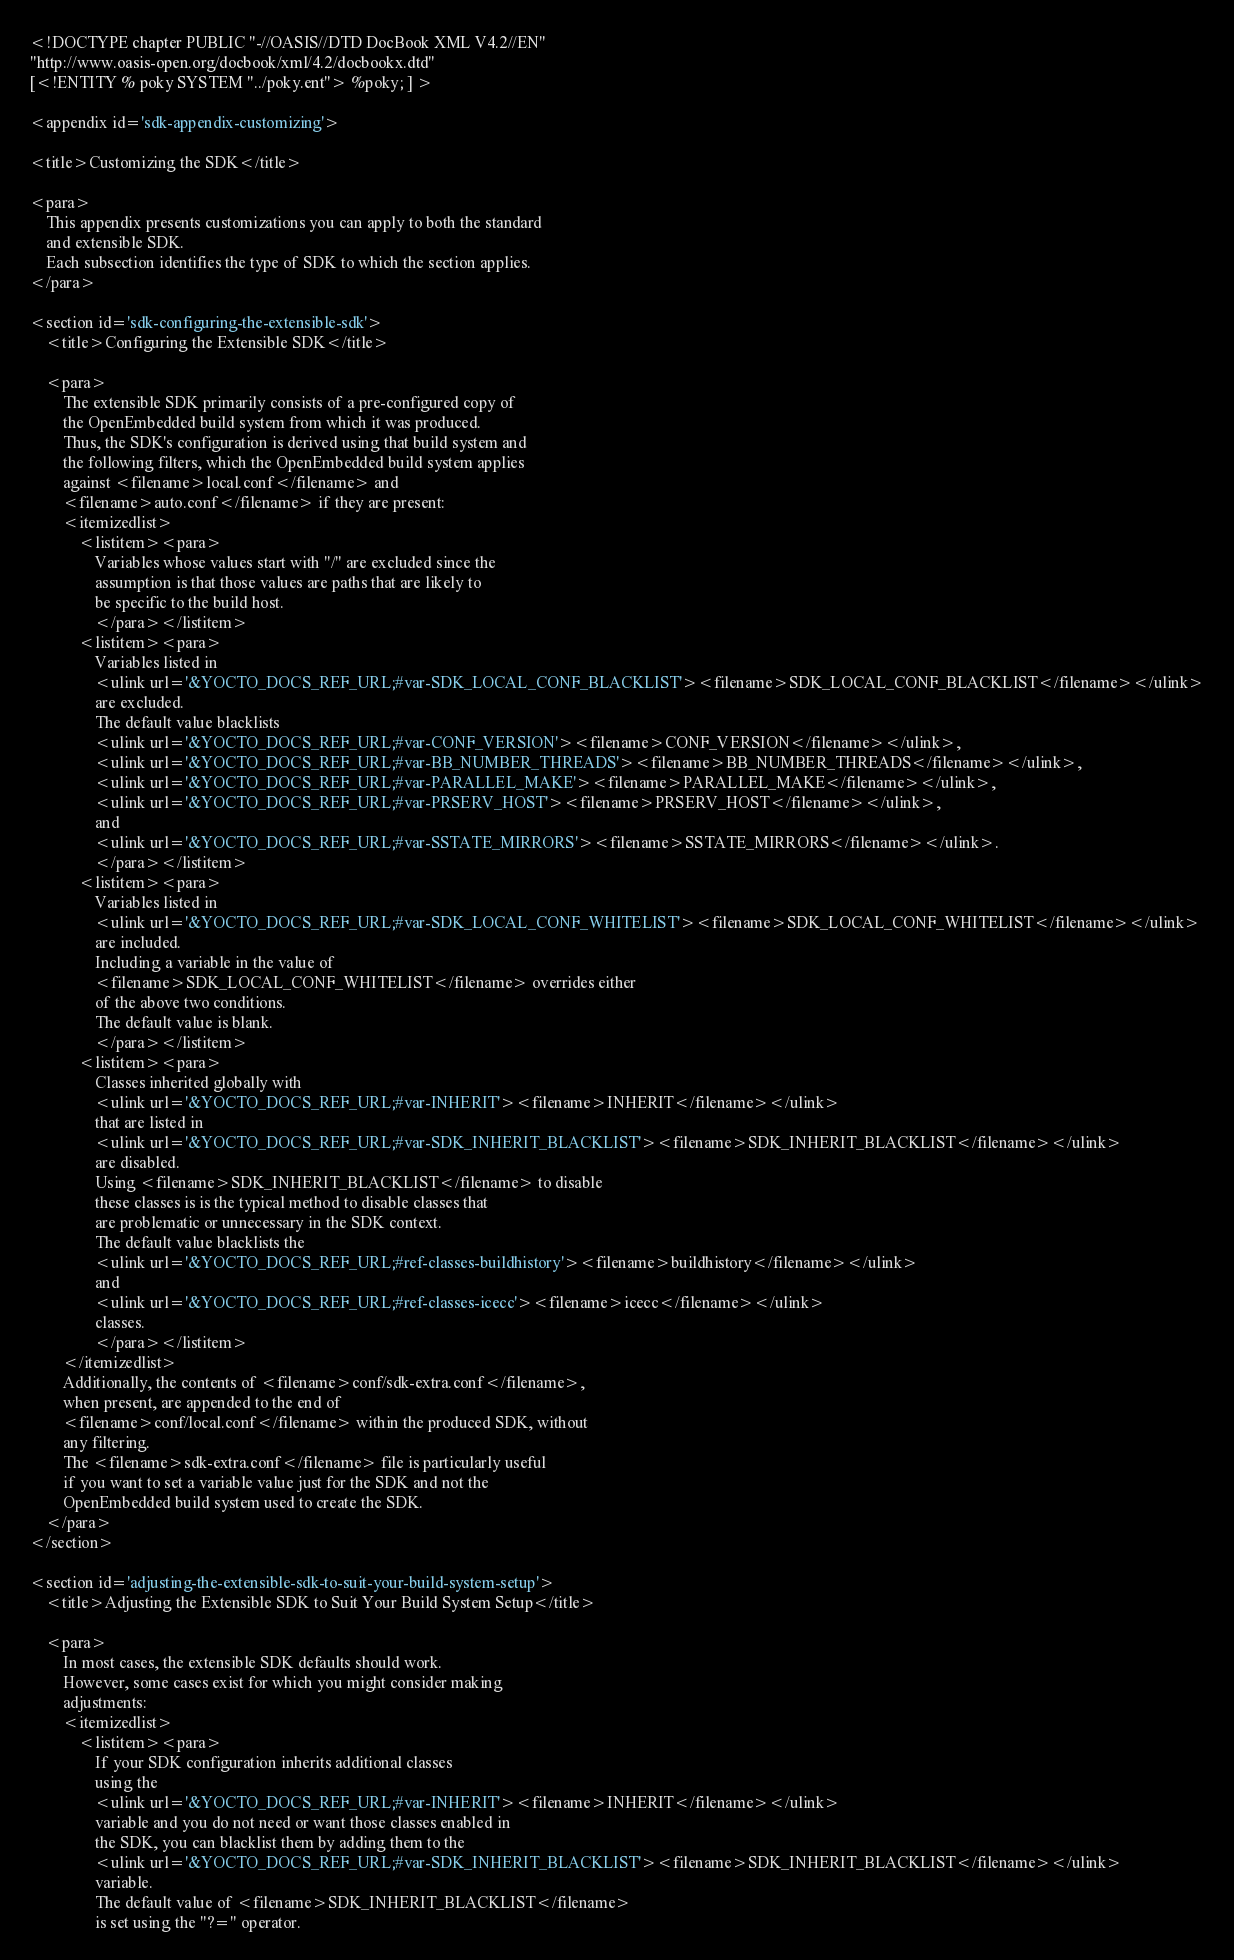Convert code to text. <code><loc_0><loc_0><loc_500><loc_500><_XML_><!DOCTYPE chapter PUBLIC "-//OASIS//DTD DocBook XML V4.2//EN"
"http://www.oasis-open.org/docbook/xml/4.2/docbookx.dtd"
[<!ENTITY % poky SYSTEM "../poky.ent"> %poky; ] >

<appendix id='sdk-appendix-customizing'>

<title>Customizing the SDK</title>

<para>
    This appendix presents customizations you can apply to both the standard
    and extensible SDK.
    Each subsection identifies the type of SDK to which the section applies.
</para>

<section id='sdk-configuring-the-extensible-sdk'>
    <title>Configuring the Extensible SDK</title>

    <para>
        The extensible SDK primarily consists of a pre-configured copy of
        the OpenEmbedded build system from which it was produced.
        Thus, the SDK's configuration is derived using that build system and
        the following filters, which the OpenEmbedded build system applies
        against <filename>local.conf</filename> and
        <filename>auto.conf</filename> if they are present:
        <itemizedlist>
            <listitem><para>
                Variables whose values start with "/" are excluded since the
                assumption is that those values are paths that are likely to
                be specific to the build host.
                </para></listitem>
            <listitem><para>
                Variables listed in
                <ulink url='&YOCTO_DOCS_REF_URL;#var-SDK_LOCAL_CONF_BLACKLIST'><filename>SDK_LOCAL_CONF_BLACKLIST</filename></ulink>
                are excluded.
                The default value blacklists
                <ulink url='&YOCTO_DOCS_REF_URL;#var-CONF_VERSION'><filename>CONF_VERSION</filename></ulink>,
                <ulink url='&YOCTO_DOCS_REF_URL;#var-BB_NUMBER_THREADS'><filename>BB_NUMBER_THREADS</filename></ulink>,
                <ulink url='&YOCTO_DOCS_REF_URL;#var-PARALLEL_MAKE'><filename>PARALLEL_MAKE</filename></ulink>,
                <ulink url='&YOCTO_DOCS_REF_URL;#var-PRSERV_HOST'><filename>PRSERV_HOST</filename></ulink>,
                and
                <ulink url='&YOCTO_DOCS_REF_URL;#var-SSTATE_MIRRORS'><filename>SSTATE_MIRRORS</filename></ulink>.
                </para></listitem>
            <listitem><para>
                Variables listed in
                <ulink url='&YOCTO_DOCS_REF_URL;#var-SDK_LOCAL_CONF_WHITELIST'><filename>SDK_LOCAL_CONF_WHITELIST</filename></ulink>
                are included.
                Including a variable in the value of
                <filename>SDK_LOCAL_CONF_WHITELIST</filename> overrides either
                of the above two conditions.
                The default value is blank.
                </para></listitem>
            <listitem><para>
                Classes inherited globally with
                <ulink url='&YOCTO_DOCS_REF_URL;#var-INHERIT'><filename>INHERIT</filename></ulink>
                that are listed in
                <ulink url='&YOCTO_DOCS_REF_URL;#var-SDK_INHERIT_BLACKLIST'><filename>SDK_INHERIT_BLACKLIST</filename></ulink>
                are disabled.
                Using <filename>SDK_INHERIT_BLACKLIST</filename> to disable
                these classes is is the typical method to disable classes that
                are problematic or unnecessary in the SDK context.
                The default value blacklists the
                <ulink url='&YOCTO_DOCS_REF_URL;#ref-classes-buildhistory'><filename>buildhistory</filename></ulink>
                and
                <ulink url='&YOCTO_DOCS_REF_URL;#ref-classes-icecc'><filename>icecc</filename></ulink>
                classes.
                </para></listitem>
        </itemizedlist>
        Additionally, the contents of <filename>conf/sdk-extra.conf</filename>,
        when present, are appended to the end of
        <filename>conf/local.conf</filename> within the produced SDK, without
        any filtering.
        The <filename>sdk-extra.conf</filename> file is particularly useful
        if you want to set a variable value just for the SDK and not the
        OpenEmbedded build system used to create the SDK.
    </para>
</section>

<section id='adjusting-the-extensible-sdk-to-suit-your-build-system-setup'>
    <title>Adjusting the Extensible SDK to Suit Your Build System Setup</title>

    <para>
        In most cases, the extensible SDK defaults should work.
        However, some cases exist for which you might consider making
        adjustments:
        <itemizedlist>
            <listitem><para>
                If your SDK configuration inherits additional classes
                using the
                <ulink url='&YOCTO_DOCS_REF_URL;#var-INHERIT'><filename>INHERIT</filename></ulink>
                variable and you do not need or want those classes enabled in
                the SDK, you can blacklist them by adding them to the
                <ulink url='&YOCTO_DOCS_REF_URL;#var-SDK_INHERIT_BLACKLIST'><filename>SDK_INHERIT_BLACKLIST</filename></ulink>
                variable.
                The default value of <filename>SDK_INHERIT_BLACKLIST</filename>
                is set using the "?=" operator.</code> 